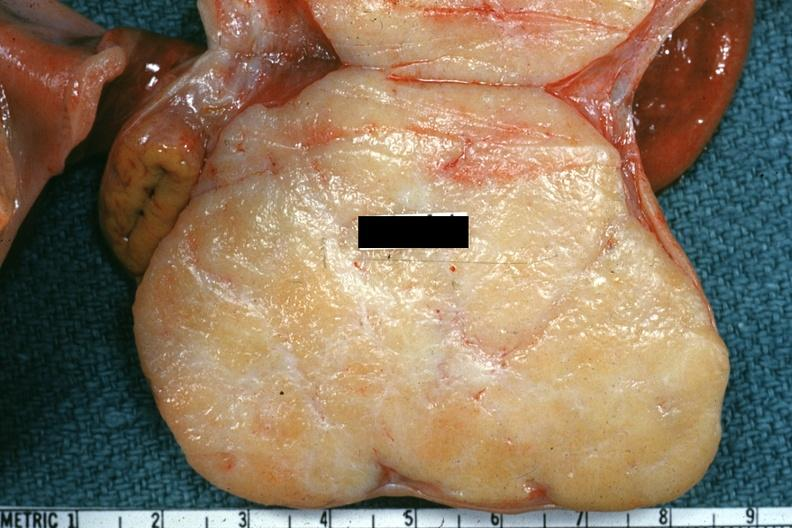s ovary present?
Answer the question using a single word or phrase. Yes 